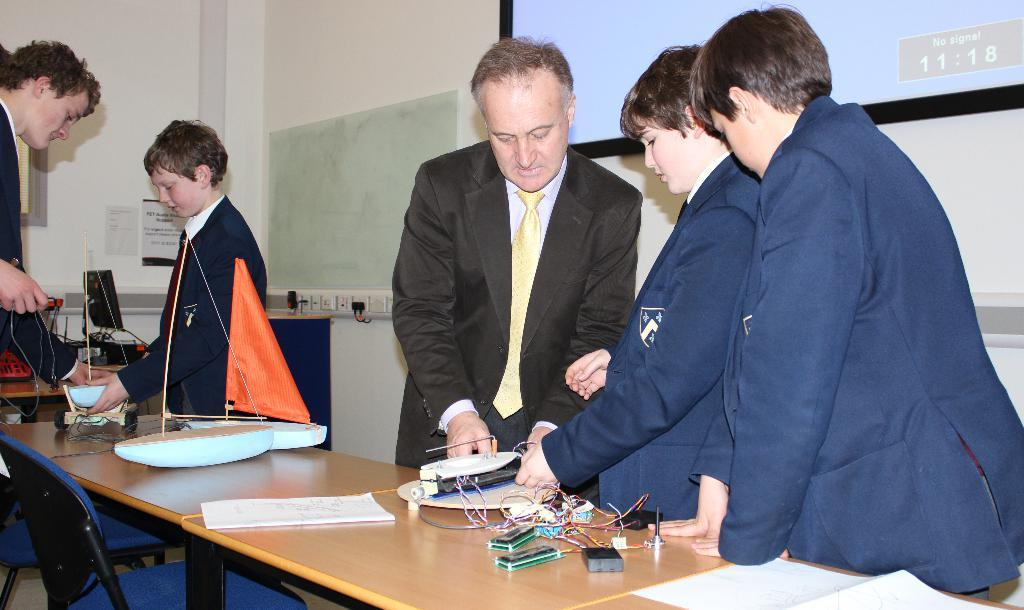How many people are present in the image? There are five people in the image. What are the people doing in the image? The people are standing around a table. What can be found on the table in the image? We start by identifying the main subject of the image, which is the five people. Then, we describe their actions and location, noting that they are standing around a table. Next, we mention the presence of things and papers on the table, which provides additional context about the scene. Finally, we acknowledge the presence of a projector screen, which suggests a possible purpose for the gathering. Absurd Question/Answer: What type of temper can be seen in the people standing around the table? There is no indication of the people's temper in the image; we can only observe their actions and location. Are there any bears present in the image? No, there are no bears visible in the image. What type of ink is being used to write on the papers on the table? There is no indication of what type of ink is being used, as we cannot see the writing instruments or the ink itself in the image. 